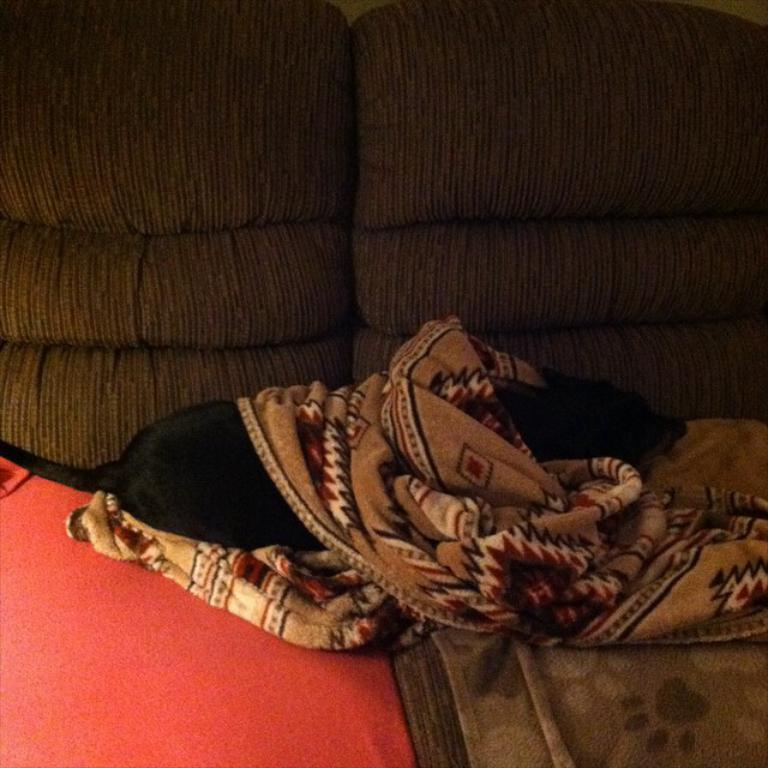What type of animal is in the image? There is a dog in the image. Where is the dog located? The dog is lying on a sofa. What else can be seen in the image besides the dog? Bed sheets are visible in the image. What type of quiver is the dog holding in the image? There is no quiver present in the image; the dog is simply lying on a sofa. 